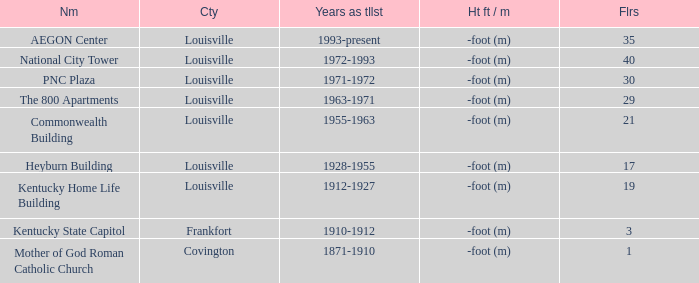What building in Louisville had more than 35 floors? National City Tower. 